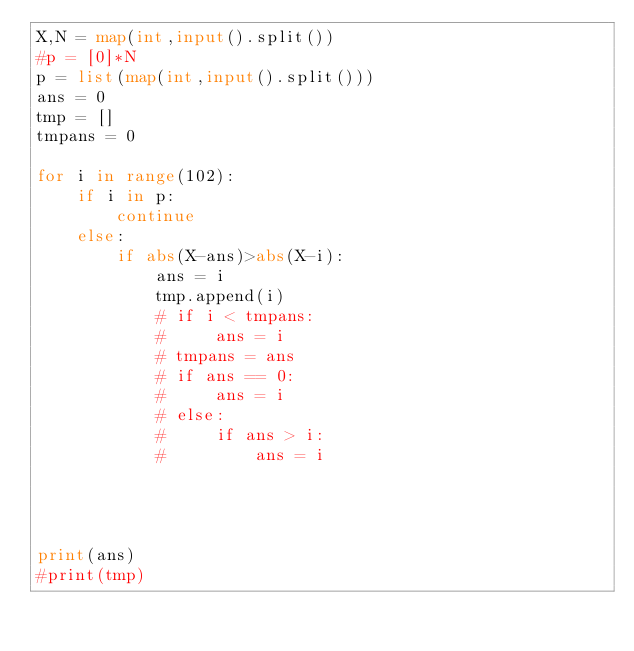Convert code to text. <code><loc_0><loc_0><loc_500><loc_500><_Python_>X,N = map(int,input().split())
#p = [0]*N
p = list(map(int,input().split()))
ans = 0
tmp = []
tmpans = 0

for i in range(102):
    if i in p:
        continue
    else:
        if abs(X-ans)>abs(X-i):
            ans = i
            tmp.append(i)
            # if i < tmpans:
            #     ans = i
            # tmpans = ans
            # if ans == 0:
            #     ans = i
            # else:
            #     if ans > i:
            #         ans = i




print(ans)
#print(tmp)</code> 